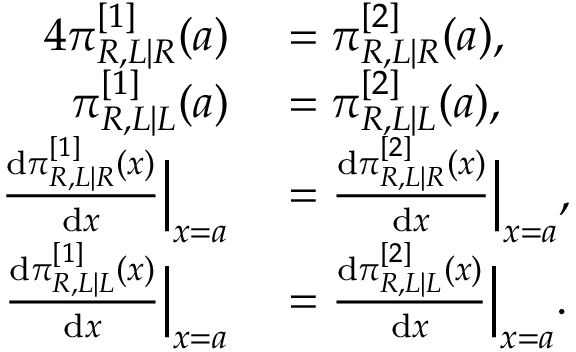Convert formula to latex. <formula><loc_0><loc_0><loc_500><loc_500>\begin{array} { r l } { { 4 } \pi _ { R , L | R } ^ { [ 1 ] } ( a ) } & = \pi _ { R , L | R } ^ { [ 2 ] } ( a ) , } \\ { \pi _ { R , L | L } ^ { [ 1 ] } ( a ) } & = \pi _ { R , L | L } ^ { [ 2 ] } ( a ) , } \\ { \frac { d \pi _ { R , L | R } ^ { [ 1 ] } ( x ) } { d x } \left | _ { x = a } } & = \frac { d \pi _ { R , L | R } ^ { [ 2 ] } ( x ) } { d x } \right | _ { x = a } , } \\ { \frac { d \pi _ { R , L | L } ^ { [ 1 ] } ( x ) } { d x } \left | _ { x = a } } & = \frac { d \pi _ { R , L | L } ^ { [ 2 ] } ( x ) } { d x } \right | _ { x = a } . } \end{array}</formula> 